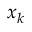<formula> <loc_0><loc_0><loc_500><loc_500>x _ { k }</formula> 